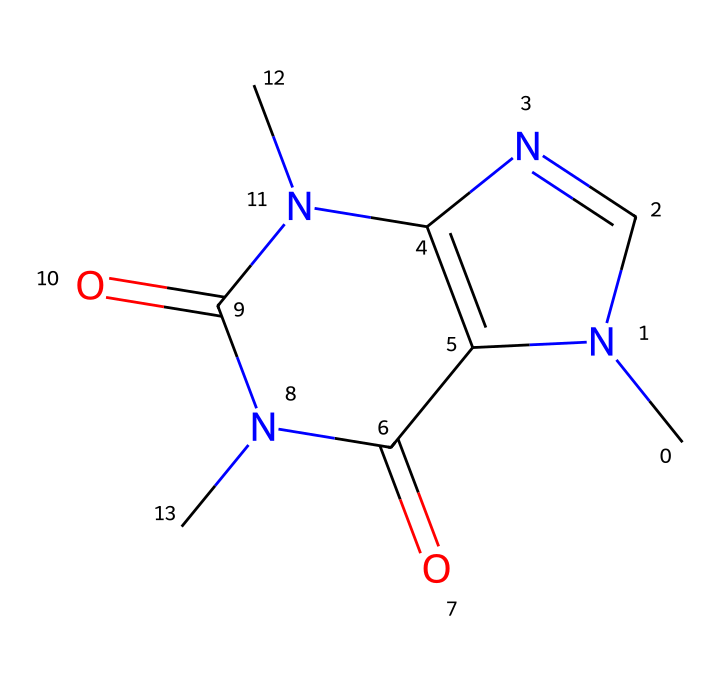How many nitrogen atoms are present in this structure? By analyzing the SMILES representation, we can count the nitrogen ('N') symbols. There are two nitrogen atoms in the structure.
Answer: two What is the functional group present in caffeine? The structure contains carbonyl groups indicated by the 'C=O' part within the structure. These are characteristic of carbonyl functional groups.
Answer: carbonyl How many rings are present in this chemical structure? We look at the cyclic nature of the structure. The 'N1' and 'N2' in the SMILES representation indicate that there are two fused rings present in the compound.
Answer: two What type of compound is caffeine categorized as? Caffeine is classified as an alkaloid based on its nitrogen-containing structure known for physiological effects, specifically, its stimulant properties.
Answer: alkaloid Is caffeine soluble in water? Caffeine is a non-electrolyte and is generally soluble in water due to hydrogen bonding with water molecules from its functional groups.
Answer: soluble What molecular formula corresponds to this structure? By analyzing the elements represented (C, H, N, O), we deduce the molecular formula of caffeine: C8H10N4O2.
Answer: C8H10N4O2 What role does caffeine play in energy drinks? Caffeine is a stimulant that enhances alertness and reduces fatigue, a key characteristic valued in energy drinks consumed during gaming.
Answer: stimulant 